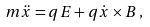Convert formula to latex. <formula><loc_0><loc_0><loc_500><loc_500>m { \ddot { x } } = q E + q { \dot { x } } \times B \, ,</formula> 